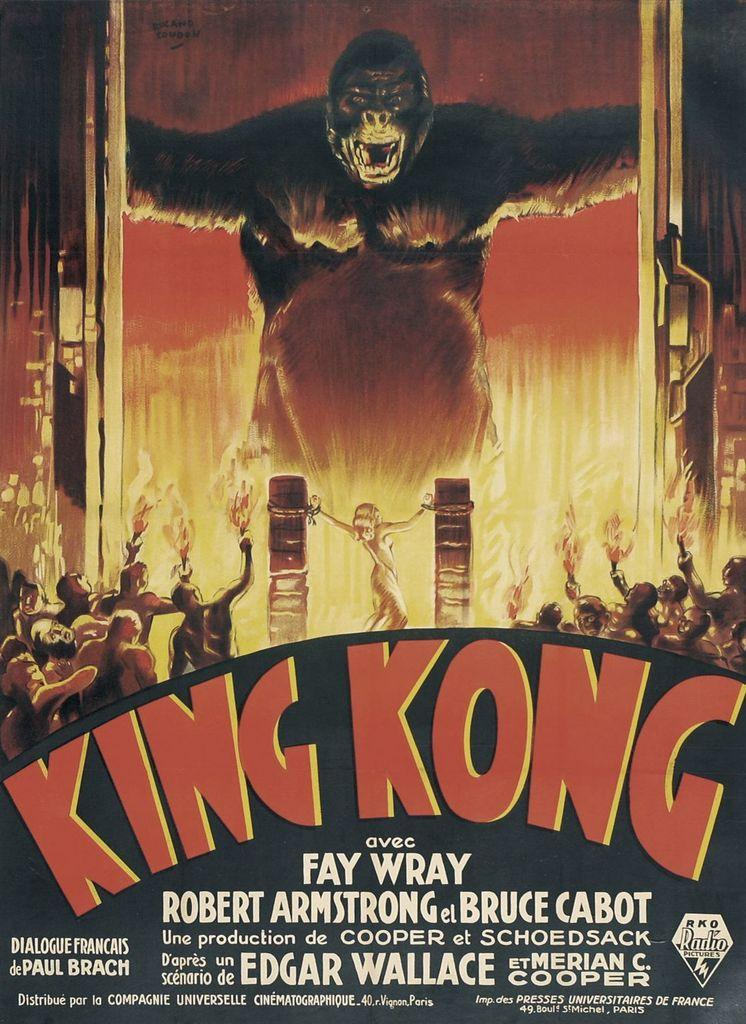<image>
Create a compact narrative representing the image presented. A poster for King Kong shows a large ape and a woman who is tied up. 